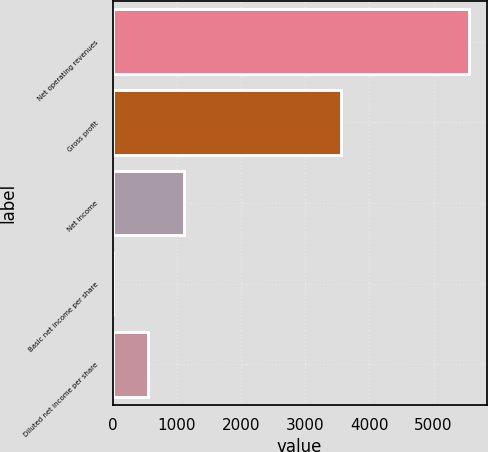Convert chart. <chart><loc_0><loc_0><loc_500><loc_500><bar_chart><fcel>Net operating revenues<fcel>Gross profit<fcel>Net income<fcel>Basic net income per share<fcel>Diluted net income per share<nl><fcel>5551<fcel>3555<fcel>1110.48<fcel>0.36<fcel>555.42<nl></chart> 